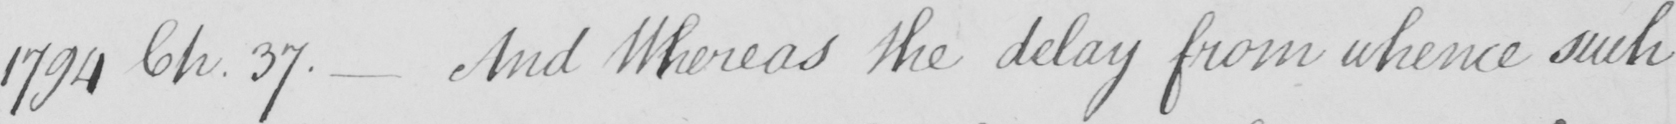Transcribe the text shown in this historical manuscript line. 1794 Ch . 37 .  _  And Whereas the delay from whence such 